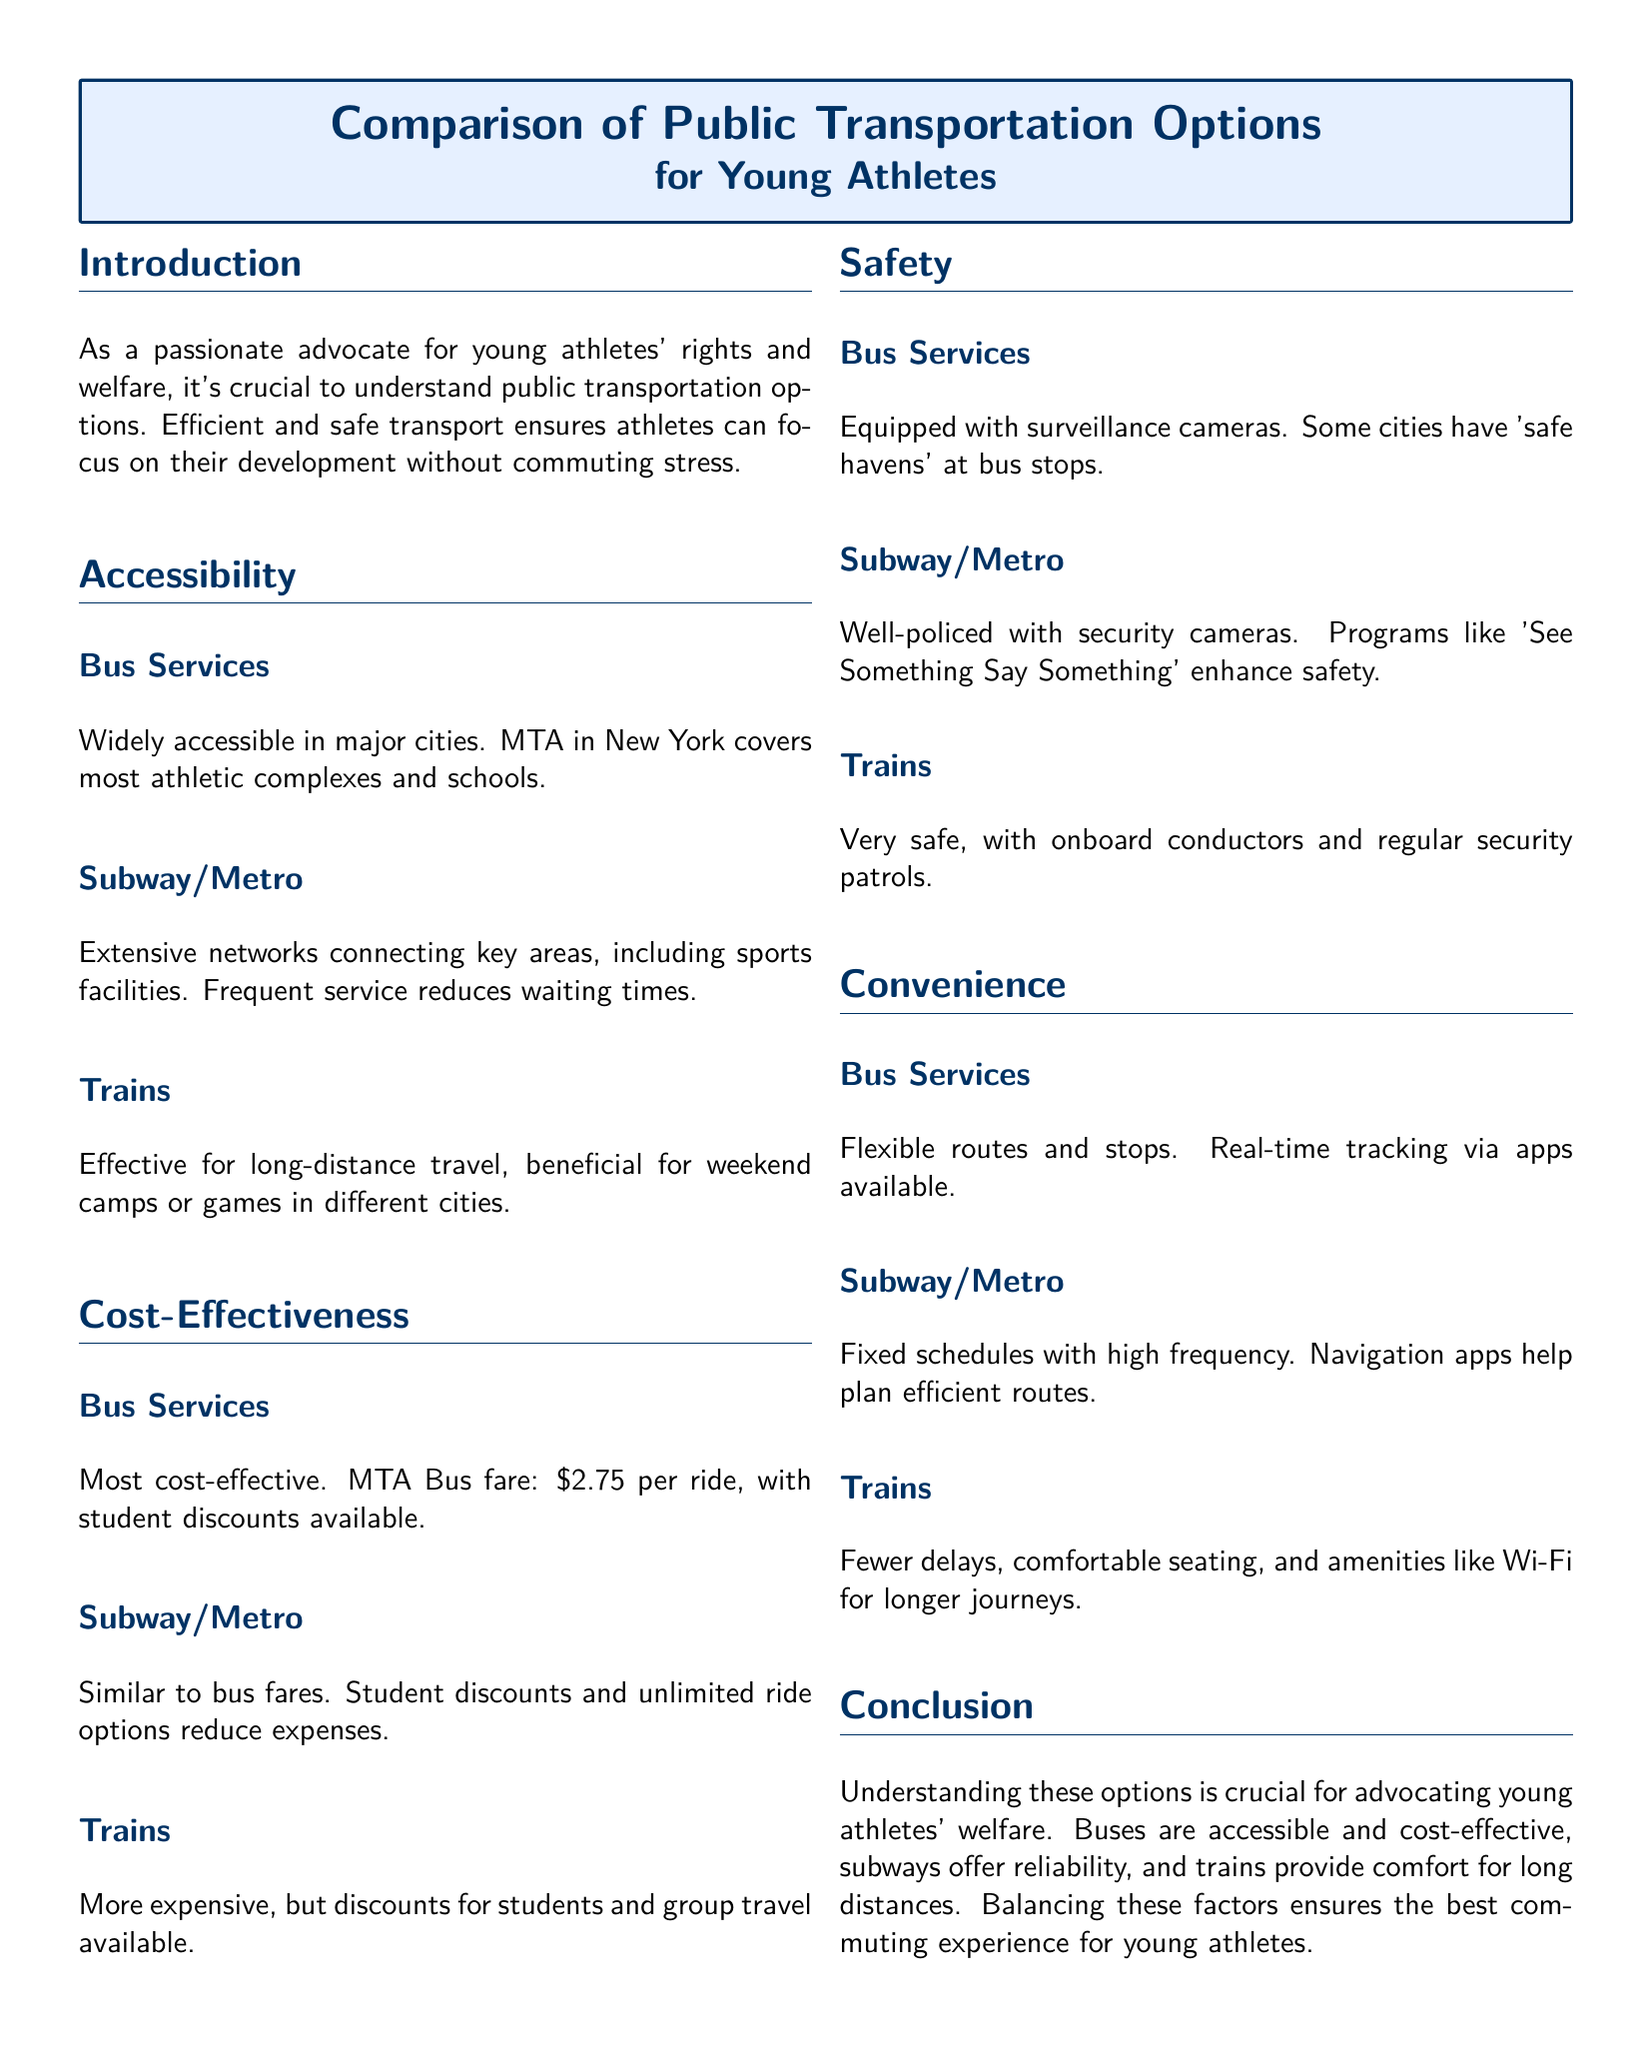What is the fare for MTA Bus? The fare for MTA Bus is mentioned in the document as $2.75 per ride.
Answer: $2.75 What safety features do bus services have? The document states that bus services are equipped with surveillance cameras and some cities have 'safe havens' at bus stops.
Answer: Surveillance cameras Which public transportation option provides real-time tracking? The document discusses that bus services offer real-time tracking via apps, indicating convenience.
Answer: Bus Services What public transportation option is noted for flexible routes? The sections on convenience specify that bus services have flexible routes and stops.
Answer: Bus Services What is the primary benefit of trains for young athletes? The document notes that trains are effective for long-distance travel, particularly for weekend camps or games in different cities.
Answer: Long-distance travel Which two public transportation options offer student discounts? The document specifies that both bus services and subway/metro options have student discounts available.
Answer: Bus Services, Subway/Metro How does subway/metro frequency benefit young athletes? The document mentions that subways have high frequency, which reduces waiting times for young athletes.
Answer: High frequency What are the two key components of safety mentioned for subways? Safety for subways involves being well-policed and having security cameras, as stated in the document.
Answer: Well-policed, security cameras Which mode of transportation provides Wi-Fi for longer journeys? The document specifies that trains offer amenities like Wi-Fi for comfort on longer journeys.
Answer: Trains 